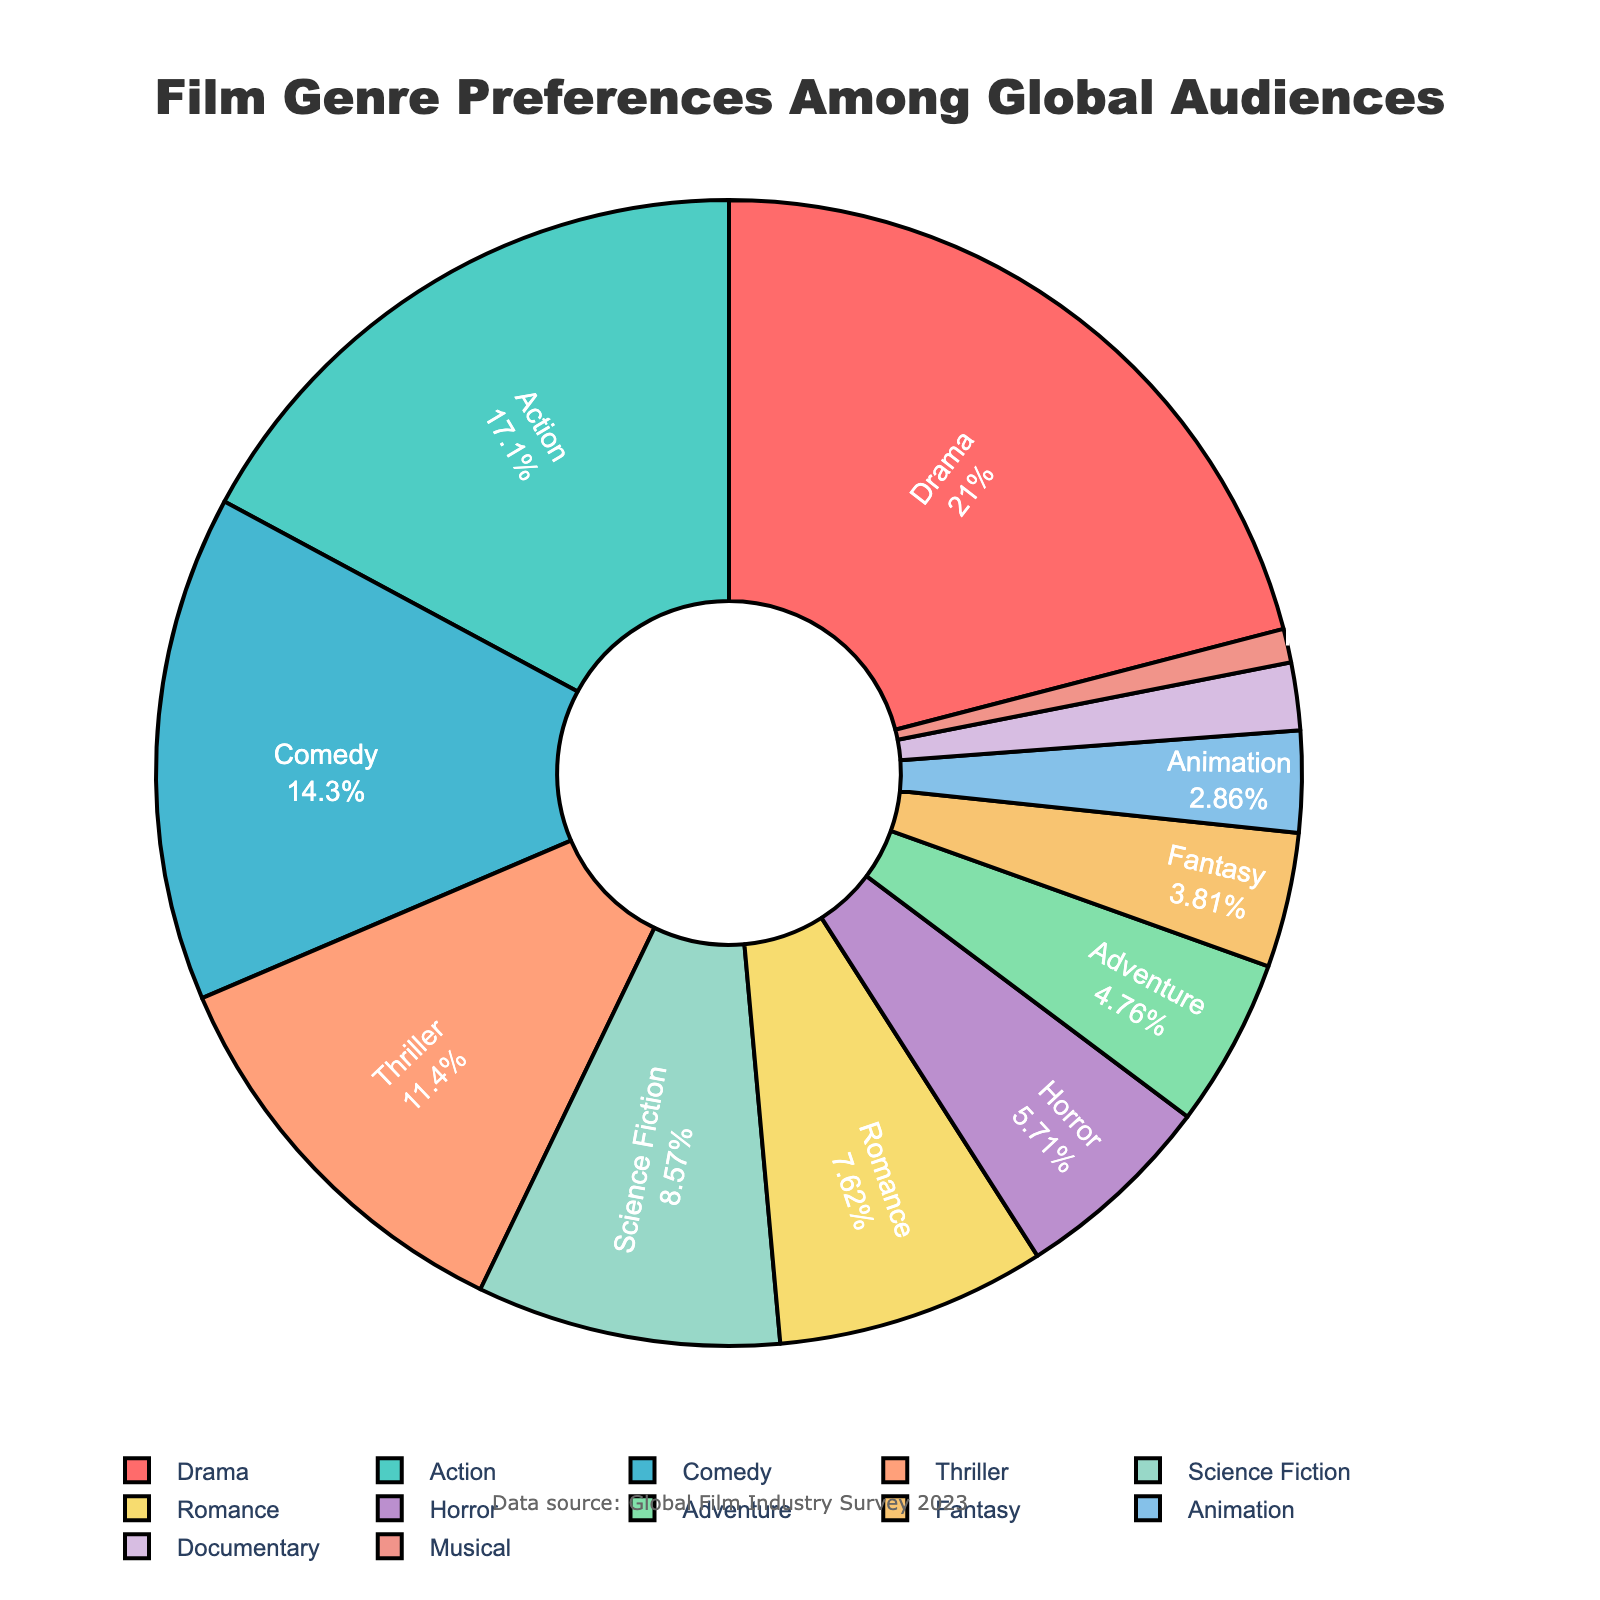What percentage of global audiences prefers Science Fiction films? Identify the Science Fiction category and read its associated percentage value in the pie chart.
Answer: 9 Which genre is most preferred among global audiences? Identify the slice in the pie chart with the largest percentage. The label on this slice is the most preferred genre.
Answer: Drama What is the combined percentage of audiences that prefer Action and Comedy films? Identify the individual percentages for Action and Comedy, then sum them up (18% + 15%).
Answer: 33 Which genre category has a larger audience preference, Horror or Adventure? Compare the percentage values of Horror and Adventure. Horror has 6%, and Adventure has 5%.
Answer: Horror What is the least preferred film genre among global audiences? Identify the slice in the pie chart with the smallest percentage. The label on this slice is the least preferred genre.
Answer: Musical What is the combined percentage of genres with a preference of 5% or less? Identify the genres with percentages of 5% or less (Adventure, Fantasy, Animation, Documentary, Musical) and sum their percentages (5% + 4% + 3% + 2% + 1%).
Answer: 15 How does the audience preference for Romance films compare to that for Thriller films? Identify the percentage values for Romance (8%) and Thriller (12%) and compare them. Thriller is more preferred than Romance.
Answer: Thriller What are the top three most preferred film genres? Identify the three genres with the highest percentages in the pie chart (Drama, Action, Comedy).
Answer: Drama, Action, Comedy By how much does the preference for Drama films exceed that for Horror films? Subtract the percentage for Horror (6%) from the percentage for Drama (22%) (22% - 6%).
Answer: 16 Which genre has the second smallest audience preference? Identify the genre with the second smallest percentage after Musical. The next smallest percentage after 1% is 2%, which belongs to Documentary.
Answer: Documentary 